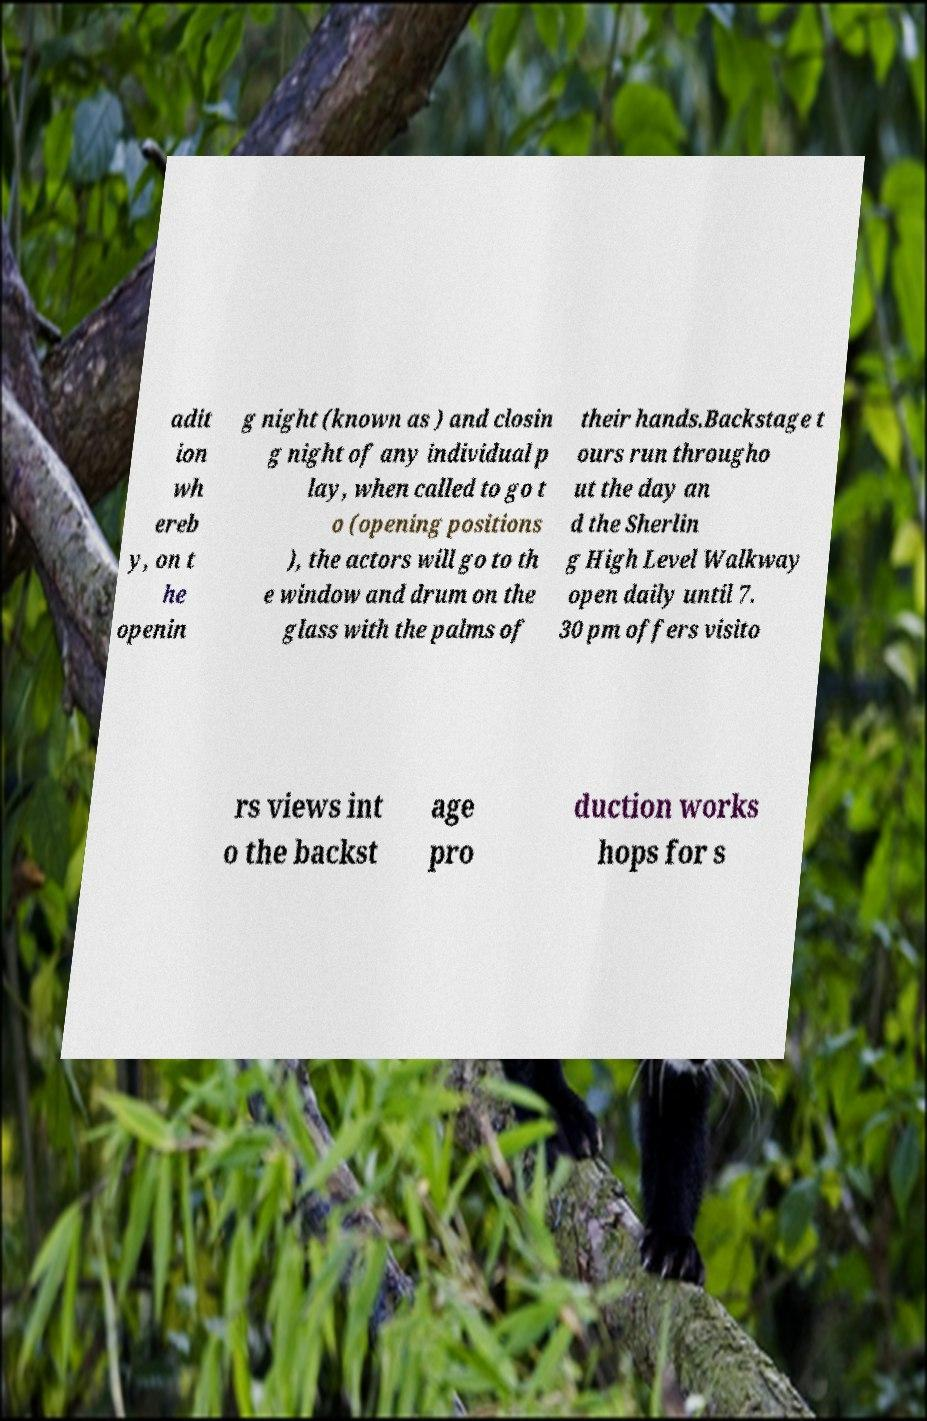For documentation purposes, I need the text within this image transcribed. Could you provide that? adit ion wh ereb y, on t he openin g night (known as ) and closin g night of any individual p lay, when called to go t o (opening positions ), the actors will go to th e window and drum on the glass with the palms of their hands.Backstage t ours run througho ut the day an d the Sherlin g High Level Walkway open daily until 7. 30 pm offers visito rs views int o the backst age pro duction works hops for s 